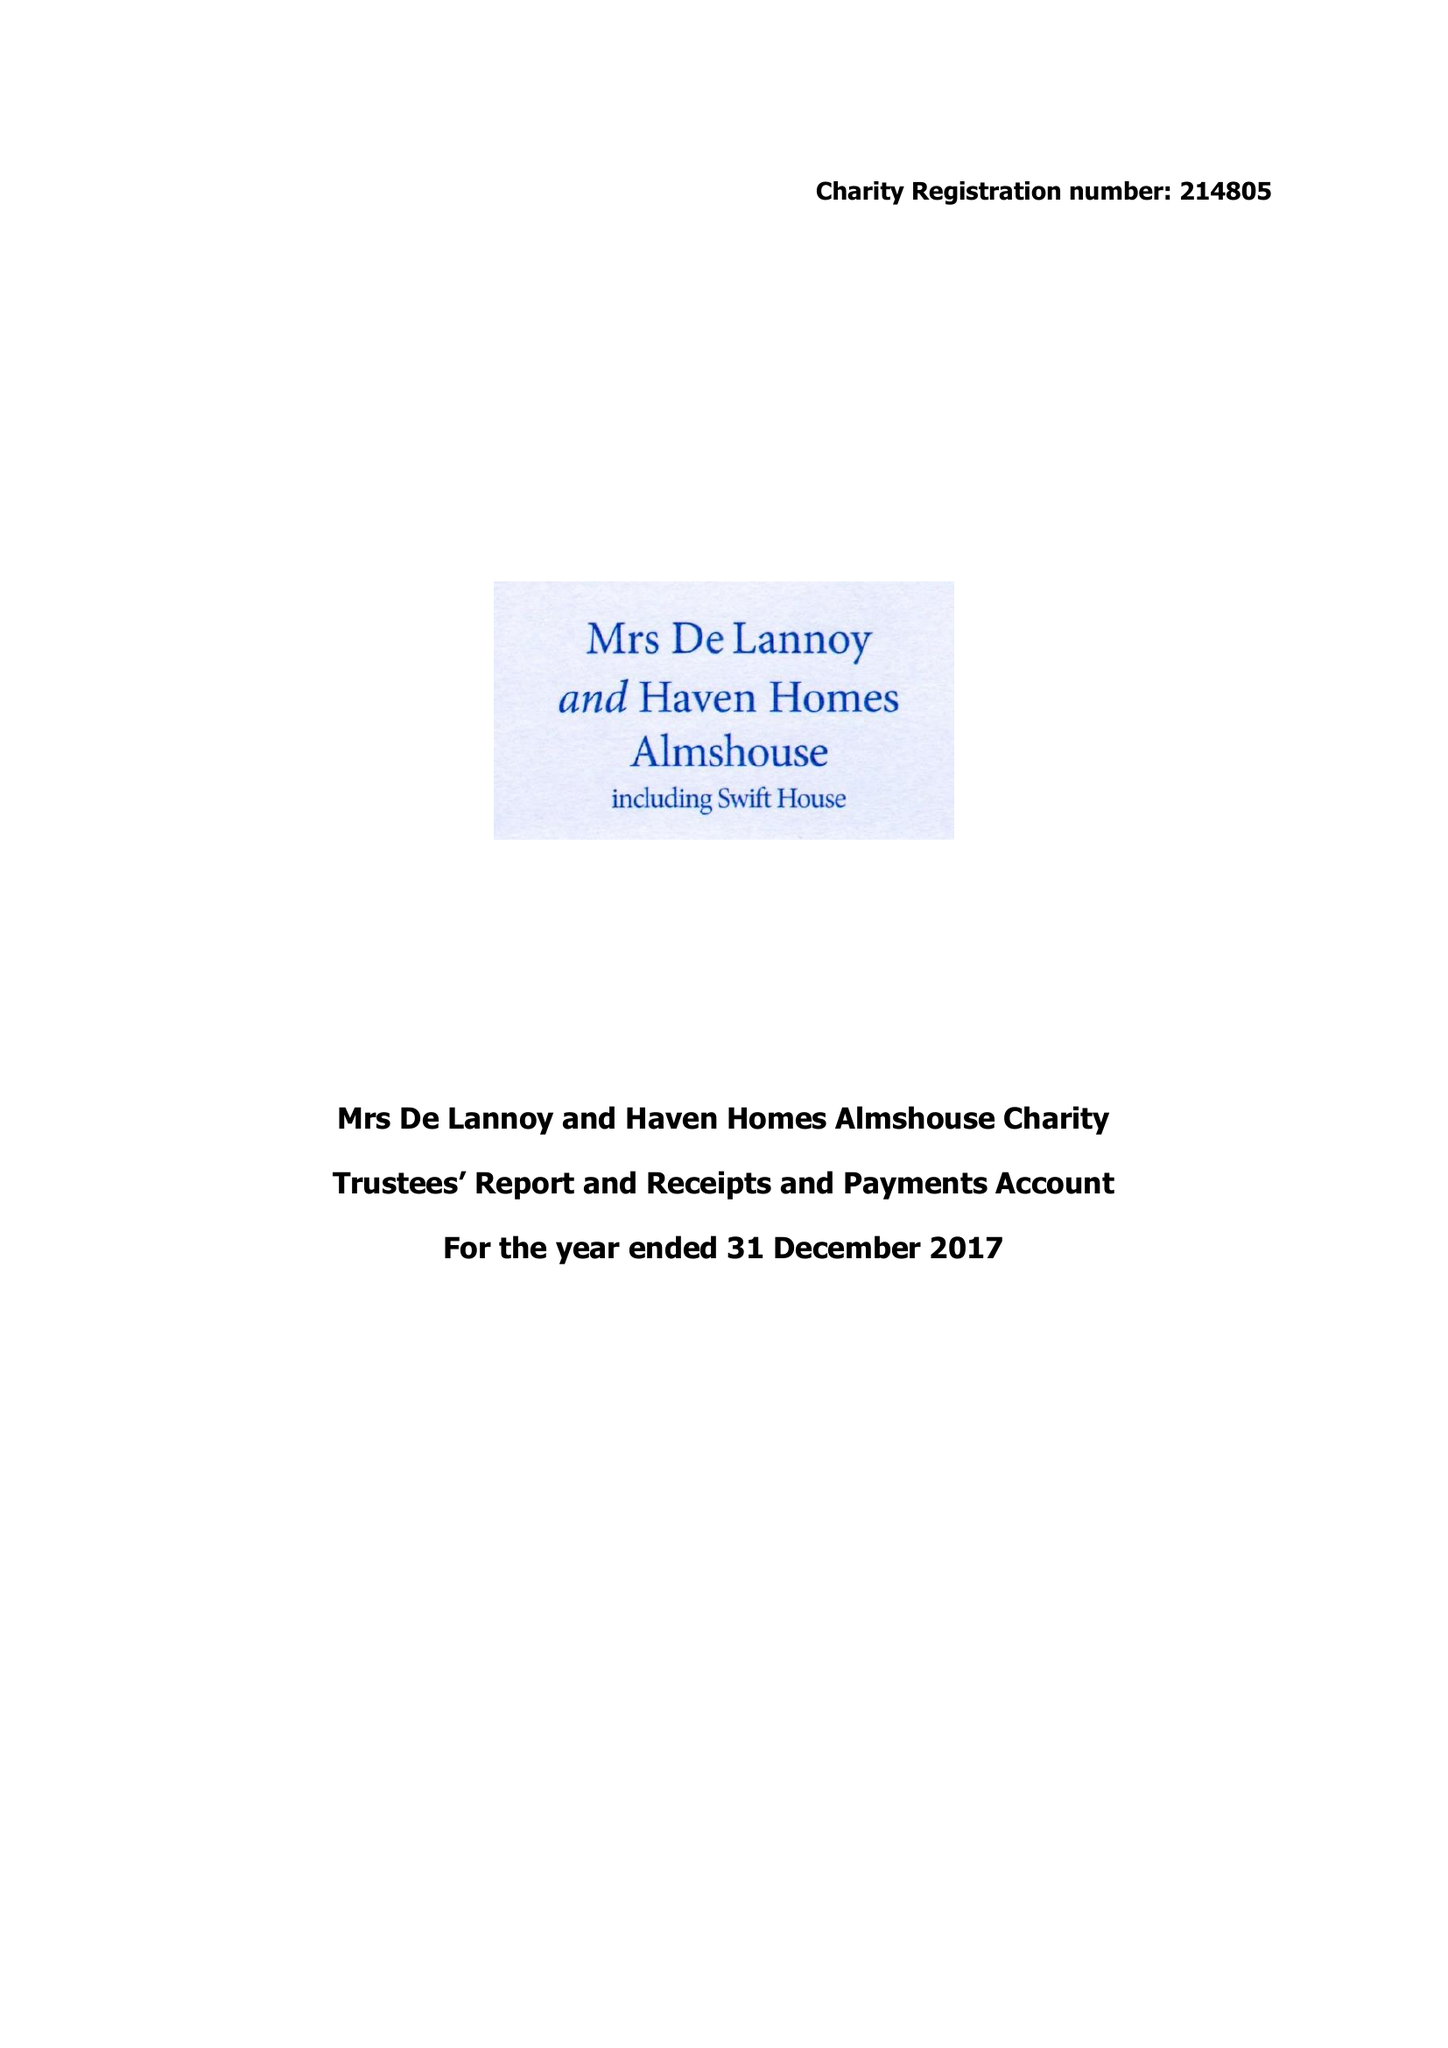What is the value for the address__post_town?
Answer the question using a single word or phrase. CROWBOROUGH 